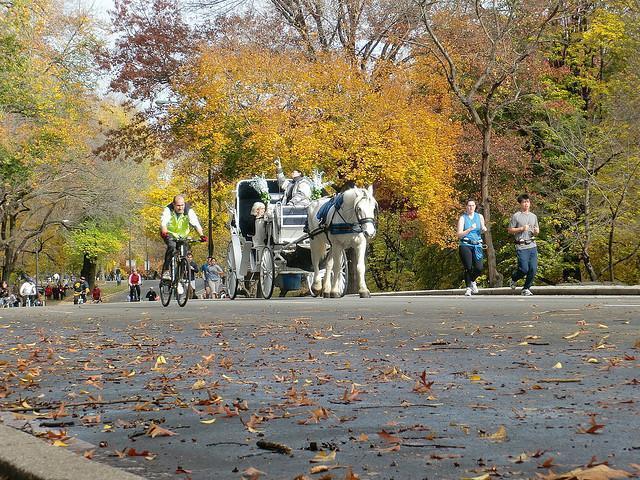How many people are there?
Give a very brief answer. 3. How many characters on the digitized reader board on the top front of the bus are numerals?
Give a very brief answer. 0. 